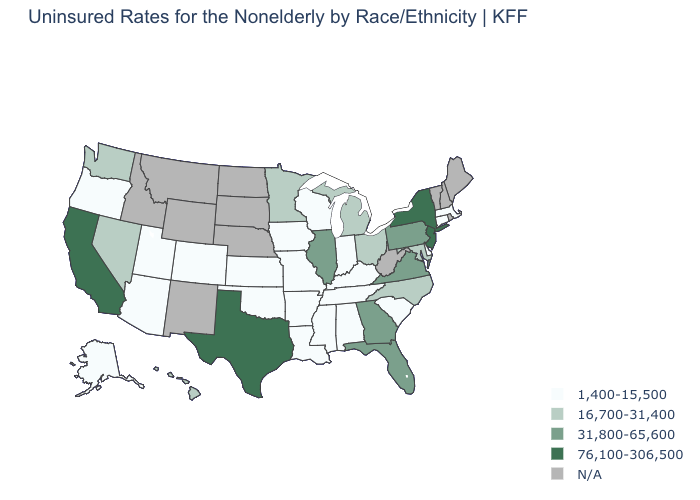Which states have the lowest value in the USA?
Short answer required. Alabama, Alaska, Arizona, Arkansas, Colorado, Connecticut, Delaware, Indiana, Iowa, Kansas, Kentucky, Louisiana, Massachusetts, Mississippi, Missouri, Oklahoma, Oregon, South Carolina, Tennessee, Utah, Wisconsin. Does the map have missing data?
Be succinct. Yes. Is the legend a continuous bar?
Quick response, please. No. What is the lowest value in states that border Rhode Island?
Keep it brief. 1,400-15,500. Name the states that have a value in the range 31,800-65,600?
Write a very short answer. Florida, Georgia, Illinois, Pennsylvania, Virginia. Does the map have missing data?
Write a very short answer. Yes. Name the states that have a value in the range 1,400-15,500?
Be succinct. Alabama, Alaska, Arizona, Arkansas, Colorado, Connecticut, Delaware, Indiana, Iowa, Kansas, Kentucky, Louisiana, Massachusetts, Mississippi, Missouri, Oklahoma, Oregon, South Carolina, Tennessee, Utah, Wisconsin. What is the highest value in the West ?
Short answer required. 76,100-306,500. What is the lowest value in states that border Nebraska?
Quick response, please. 1,400-15,500. Does Alabama have the highest value in the USA?
Concise answer only. No. Does New York have the lowest value in the Northeast?
Write a very short answer. No. What is the value of Utah?
Quick response, please. 1,400-15,500. Name the states that have a value in the range N/A?
Write a very short answer. Idaho, Maine, Montana, Nebraska, New Hampshire, New Mexico, North Dakota, Rhode Island, South Dakota, Vermont, West Virginia, Wyoming. 